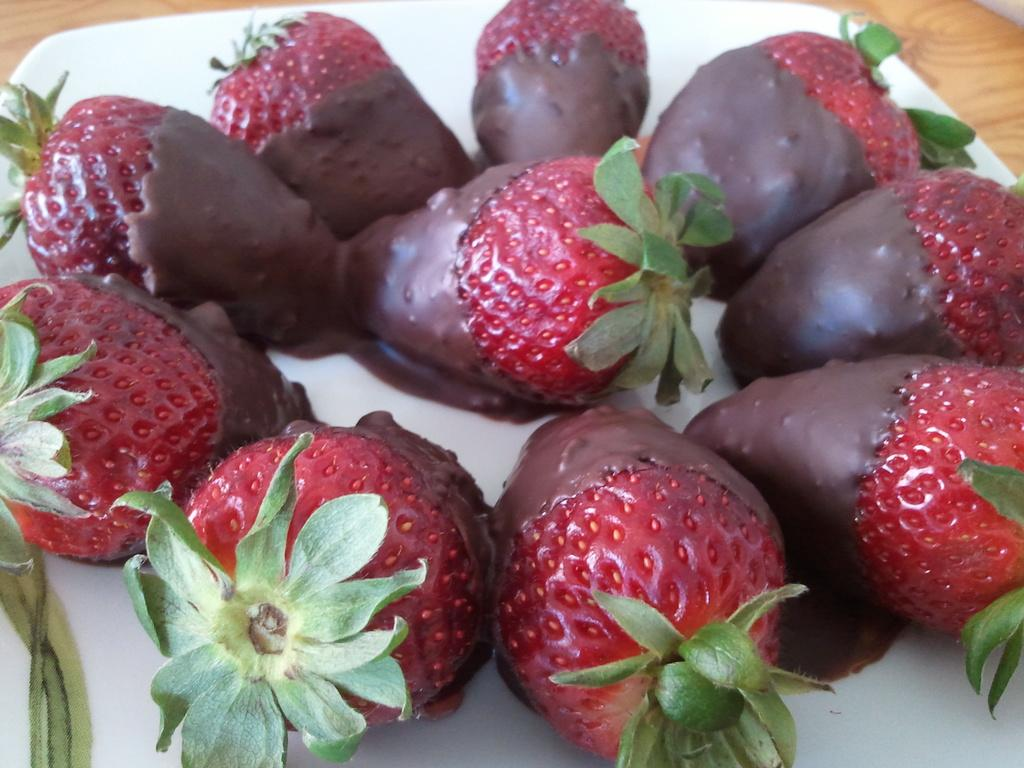What is the main object in the center of the image? There is a plate in the center of the image. What is on the plate? The plate contains strawberries. What is added to the strawberries? There is chocolate on the strawberries. What type of company is represented by the fowl in the image? There is no fowl present in the image, so it is not possible to determine what type of company it might represent. 